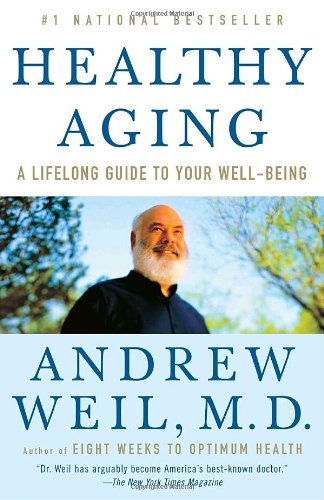Who wrote this book? The book 'Healthy Aging: A Lifelong Guide to Your Well-Being' is written by Dr. Andrew Weil M.D., a prominent figure in the field of health and wellness. 